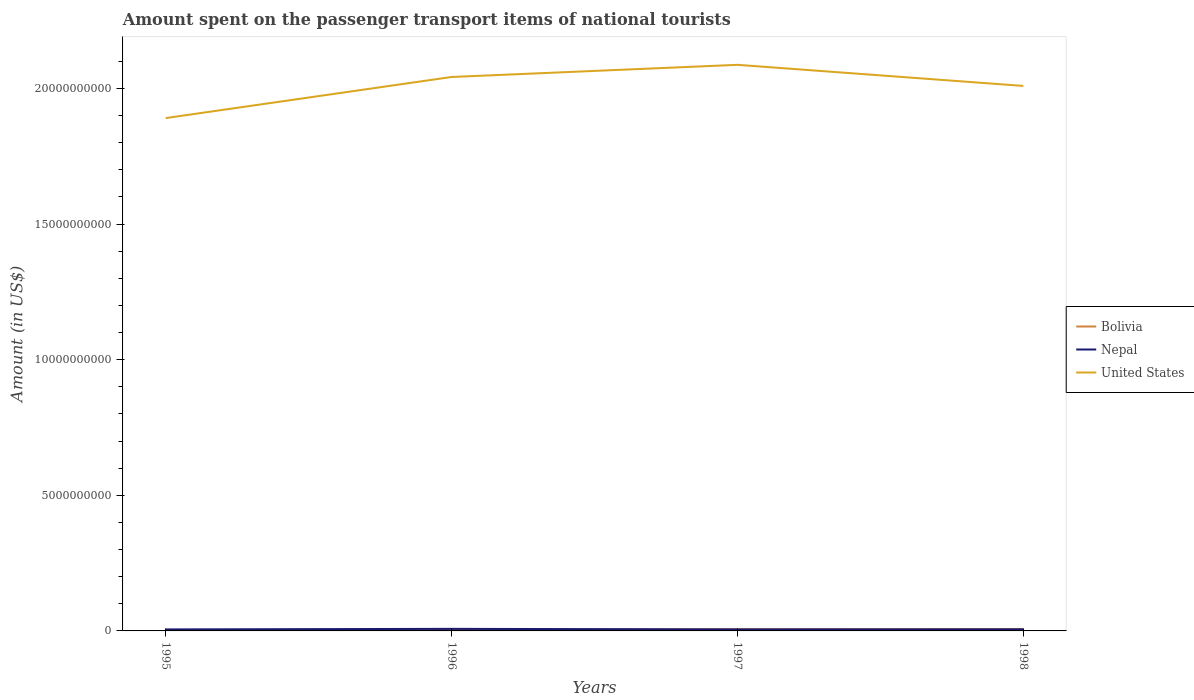Across all years, what is the maximum amount spent on the passenger transport items of national tourists in United States?
Give a very brief answer. 1.89e+1. In which year was the amount spent on the passenger transport items of national tourists in United States maximum?
Provide a succinct answer. 1995. What is the total amount spent on the passenger transport items of national tourists in United States in the graph?
Offer a terse response. 3.30e+08. What is the difference between the highest and the second highest amount spent on the passenger transport items of national tourists in United States?
Offer a very short reply. 1.96e+09. How many years are there in the graph?
Your answer should be compact. 4. What is the difference between two consecutive major ticks on the Y-axis?
Ensure brevity in your answer.  5.00e+09. Does the graph contain any zero values?
Provide a succinct answer. No. How many legend labels are there?
Provide a succinct answer. 3. What is the title of the graph?
Offer a very short reply. Amount spent on the passenger transport items of national tourists. What is the Amount (in US$) of Bolivia in 1995?
Your response must be concise. 3.70e+07. What is the Amount (in US$) in Nepal in 1995?
Keep it short and to the point. 5.50e+07. What is the Amount (in US$) of United States in 1995?
Provide a short and direct response. 1.89e+1. What is the Amount (in US$) in Bolivia in 1996?
Make the answer very short. 3.90e+07. What is the Amount (in US$) in Nepal in 1996?
Give a very brief answer. 7.60e+07. What is the Amount (in US$) in United States in 1996?
Give a very brief answer. 2.04e+1. What is the Amount (in US$) of Bolivia in 1997?
Ensure brevity in your answer.  6.50e+07. What is the Amount (in US$) of Nepal in 1997?
Provide a succinct answer. 5.50e+07. What is the Amount (in US$) in United States in 1997?
Your answer should be compact. 2.09e+1. What is the Amount (in US$) of Bolivia in 1998?
Offer a very short reply. 6.80e+07. What is the Amount (in US$) in Nepal in 1998?
Keep it short and to the point. 5.90e+07. What is the Amount (in US$) in United States in 1998?
Provide a succinct answer. 2.01e+1. Across all years, what is the maximum Amount (in US$) of Bolivia?
Ensure brevity in your answer.  6.80e+07. Across all years, what is the maximum Amount (in US$) of Nepal?
Make the answer very short. 7.60e+07. Across all years, what is the maximum Amount (in US$) in United States?
Provide a succinct answer. 2.09e+1. Across all years, what is the minimum Amount (in US$) of Bolivia?
Provide a succinct answer. 3.70e+07. Across all years, what is the minimum Amount (in US$) in Nepal?
Your answer should be very brief. 5.50e+07. Across all years, what is the minimum Amount (in US$) of United States?
Your answer should be very brief. 1.89e+1. What is the total Amount (in US$) in Bolivia in the graph?
Give a very brief answer. 2.09e+08. What is the total Amount (in US$) in Nepal in the graph?
Provide a short and direct response. 2.45e+08. What is the total Amount (in US$) of United States in the graph?
Offer a terse response. 8.03e+1. What is the difference between the Amount (in US$) in Nepal in 1995 and that in 1996?
Offer a terse response. -2.10e+07. What is the difference between the Amount (in US$) in United States in 1995 and that in 1996?
Provide a succinct answer. -1.52e+09. What is the difference between the Amount (in US$) of Bolivia in 1995 and that in 1997?
Keep it short and to the point. -2.80e+07. What is the difference between the Amount (in US$) in United States in 1995 and that in 1997?
Offer a terse response. -1.96e+09. What is the difference between the Amount (in US$) in Bolivia in 1995 and that in 1998?
Give a very brief answer. -3.10e+07. What is the difference between the Amount (in US$) in Nepal in 1995 and that in 1998?
Provide a succinct answer. -4.00e+06. What is the difference between the Amount (in US$) of United States in 1995 and that in 1998?
Your answer should be compact. -1.18e+09. What is the difference between the Amount (in US$) of Bolivia in 1996 and that in 1997?
Make the answer very short. -2.60e+07. What is the difference between the Amount (in US$) of Nepal in 1996 and that in 1997?
Offer a very short reply. 2.10e+07. What is the difference between the Amount (in US$) of United States in 1996 and that in 1997?
Offer a terse response. -4.48e+08. What is the difference between the Amount (in US$) of Bolivia in 1996 and that in 1998?
Provide a succinct answer. -2.90e+07. What is the difference between the Amount (in US$) of Nepal in 1996 and that in 1998?
Your answer should be very brief. 1.70e+07. What is the difference between the Amount (in US$) of United States in 1996 and that in 1998?
Ensure brevity in your answer.  3.30e+08. What is the difference between the Amount (in US$) of Bolivia in 1997 and that in 1998?
Provide a short and direct response. -3.00e+06. What is the difference between the Amount (in US$) in Nepal in 1997 and that in 1998?
Give a very brief answer. -4.00e+06. What is the difference between the Amount (in US$) of United States in 1997 and that in 1998?
Offer a terse response. 7.78e+08. What is the difference between the Amount (in US$) in Bolivia in 1995 and the Amount (in US$) in Nepal in 1996?
Offer a very short reply. -3.90e+07. What is the difference between the Amount (in US$) in Bolivia in 1995 and the Amount (in US$) in United States in 1996?
Provide a succinct answer. -2.04e+1. What is the difference between the Amount (in US$) of Nepal in 1995 and the Amount (in US$) of United States in 1996?
Make the answer very short. -2.04e+1. What is the difference between the Amount (in US$) of Bolivia in 1995 and the Amount (in US$) of Nepal in 1997?
Offer a very short reply. -1.80e+07. What is the difference between the Amount (in US$) in Bolivia in 1995 and the Amount (in US$) in United States in 1997?
Keep it short and to the point. -2.08e+1. What is the difference between the Amount (in US$) in Nepal in 1995 and the Amount (in US$) in United States in 1997?
Provide a short and direct response. -2.08e+1. What is the difference between the Amount (in US$) in Bolivia in 1995 and the Amount (in US$) in Nepal in 1998?
Your answer should be very brief. -2.20e+07. What is the difference between the Amount (in US$) of Bolivia in 1995 and the Amount (in US$) of United States in 1998?
Provide a short and direct response. -2.01e+1. What is the difference between the Amount (in US$) in Nepal in 1995 and the Amount (in US$) in United States in 1998?
Keep it short and to the point. -2.00e+1. What is the difference between the Amount (in US$) of Bolivia in 1996 and the Amount (in US$) of Nepal in 1997?
Your answer should be very brief. -1.60e+07. What is the difference between the Amount (in US$) in Bolivia in 1996 and the Amount (in US$) in United States in 1997?
Keep it short and to the point. -2.08e+1. What is the difference between the Amount (in US$) in Nepal in 1996 and the Amount (in US$) in United States in 1997?
Offer a terse response. -2.08e+1. What is the difference between the Amount (in US$) of Bolivia in 1996 and the Amount (in US$) of Nepal in 1998?
Provide a succinct answer. -2.00e+07. What is the difference between the Amount (in US$) in Bolivia in 1996 and the Amount (in US$) in United States in 1998?
Offer a terse response. -2.01e+1. What is the difference between the Amount (in US$) of Nepal in 1996 and the Amount (in US$) of United States in 1998?
Keep it short and to the point. -2.00e+1. What is the difference between the Amount (in US$) of Bolivia in 1997 and the Amount (in US$) of Nepal in 1998?
Keep it short and to the point. 6.00e+06. What is the difference between the Amount (in US$) of Bolivia in 1997 and the Amount (in US$) of United States in 1998?
Offer a terse response. -2.00e+1. What is the difference between the Amount (in US$) in Nepal in 1997 and the Amount (in US$) in United States in 1998?
Provide a short and direct response. -2.00e+1. What is the average Amount (in US$) in Bolivia per year?
Keep it short and to the point. 5.22e+07. What is the average Amount (in US$) of Nepal per year?
Give a very brief answer. 6.12e+07. What is the average Amount (in US$) in United States per year?
Ensure brevity in your answer.  2.01e+1. In the year 1995, what is the difference between the Amount (in US$) of Bolivia and Amount (in US$) of Nepal?
Ensure brevity in your answer.  -1.80e+07. In the year 1995, what is the difference between the Amount (in US$) of Bolivia and Amount (in US$) of United States?
Provide a succinct answer. -1.89e+1. In the year 1995, what is the difference between the Amount (in US$) of Nepal and Amount (in US$) of United States?
Provide a short and direct response. -1.89e+1. In the year 1996, what is the difference between the Amount (in US$) of Bolivia and Amount (in US$) of Nepal?
Give a very brief answer. -3.70e+07. In the year 1996, what is the difference between the Amount (in US$) of Bolivia and Amount (in US$) of United States?
Ensure brevity in your answer.  -2.04e+1. In the year 1996, what is the difference between the Amount (in US$) in Nepal and Amount (in US$) in United States?
Ensure brevity in your answer.  -2.03e+1. In the year 1997, what is the difference between the Amount (in US$) in Bolivia and Amount (in US$) in Nepal?
Ensure brevity in your answer.  1.00e+07. In the year 1997, what is the difference between the Amount (in US$) in Bolivia and Amount (in US$) in United States?
Ensure brevity in your answer.  -2.08e+1. In the year 1997, what is the difference between the Amount (in US$) of Nepal and Amount (in US$) of United States?
Give a very brief answer. -2.08e+1. In the year 1998, what is the difference between the Amount (in US$) in Bolivia and Amount (in US$) in Nepal?
Your answer should be very brief. 9.00e+06. In the year 1998, what is the difference between the Amount (in US$) of Bolivia and Amount (in US$) of United States?
Offer a very short reply. -2.00e+1. In the year 1998, what is the difference between the Amount (in US$) in Nepal and Amount (in US$) in United States?
Provide a short and direct response. -2.00e+1. What is the ratio of the Amount (in US$) of Bolivia in 1995 to that in 1996?
Keep it short and to the point. 0.95. What is the ratio of the Amount (in US$) in Nepal in 1995 to that in 1996?
Make the answer very short. 0.72. What is the ratio of the Amount (in US$) of United States in 1995 to that in 1996?
Provide a succinct answer. 0.93. What is the ratio of the Amount (in US$) in Bolivia in 1995 to that in 1997?
Provide a short and direct response. 0.57. What is the ratio of the Amount (in US$) in United States in 1995 to that in 1997?
Offer a very short reply. 0.91. What is the ratio of the Amount (in US$) of Bolivia in 1995 to that in 1998?
Your answer should be compact. 0.54. What is the ratio of the Amount (in US$) in Nepal in 1995 to that in 1998?
Keep it short and to the point. 0.93. What is the ratio of the Amount (in US$) in United States in 1995 to that in 1998?
Offer a terse response. 0.94. What is the ratio of the Amount (in US$) in Bolivia in 1996 to that in 1997?
Give a very brief answer. 0.6. What is the ratio of the Amount (in US$) of Nepal in 1996 to that in 1997?
Your answer should be very brief. 1.38. What is the ratio of the Amount (in US$) in United States in 1996 to that in 1997?
Provide a short and direct response. 0.98. What is the ratio of the Amount (in US$) in Bolivia in 1996 to that in 1998?
Provide a short and direct response. 0.57. What is the ratio of the Amount (in US$) of Nepal in 1996 to that in 1998?
Your response must be concise. 1.29. What is the ratio of the Amount (in US$) of United States in 1996 to that in 1998?
Provide a short and direct response. 1.02. What is the ratio of the Amount (in US$) of Bolivia in 1997 to that in 1998?
Keep it short and to the point. 0.96. What is the ratio of the Amount (in US$) of Nepal in 1997 to that in 1998?
Ensure brevity in your answer.  0.93. What is the ratio of the Amount (in US$) in United States in 1997 to that in 1998?
Offer a terse response. 1.04. What is the difference between the highest and the second highest Amount (in US$) of Nepal?
Ensure brevity in your answer.  1.70e+07. What is the difference between the highest and the second highest Amount (in US$) of United States?
Your answer should be compact. 4.48e+08. What is the difference between the highest and the lowest Amount (in US$) in Bolivia?
Your answer should be very brief. 3.10e+07. What is the difference between the highest and the lowest Amount (in US$) of Nepal?
Give a very brief answer. 2.10e+07. What is the difference between the highest and the lowest Amount (in US$) of United States?
Your answer should be very brief. 1.96e+09. 